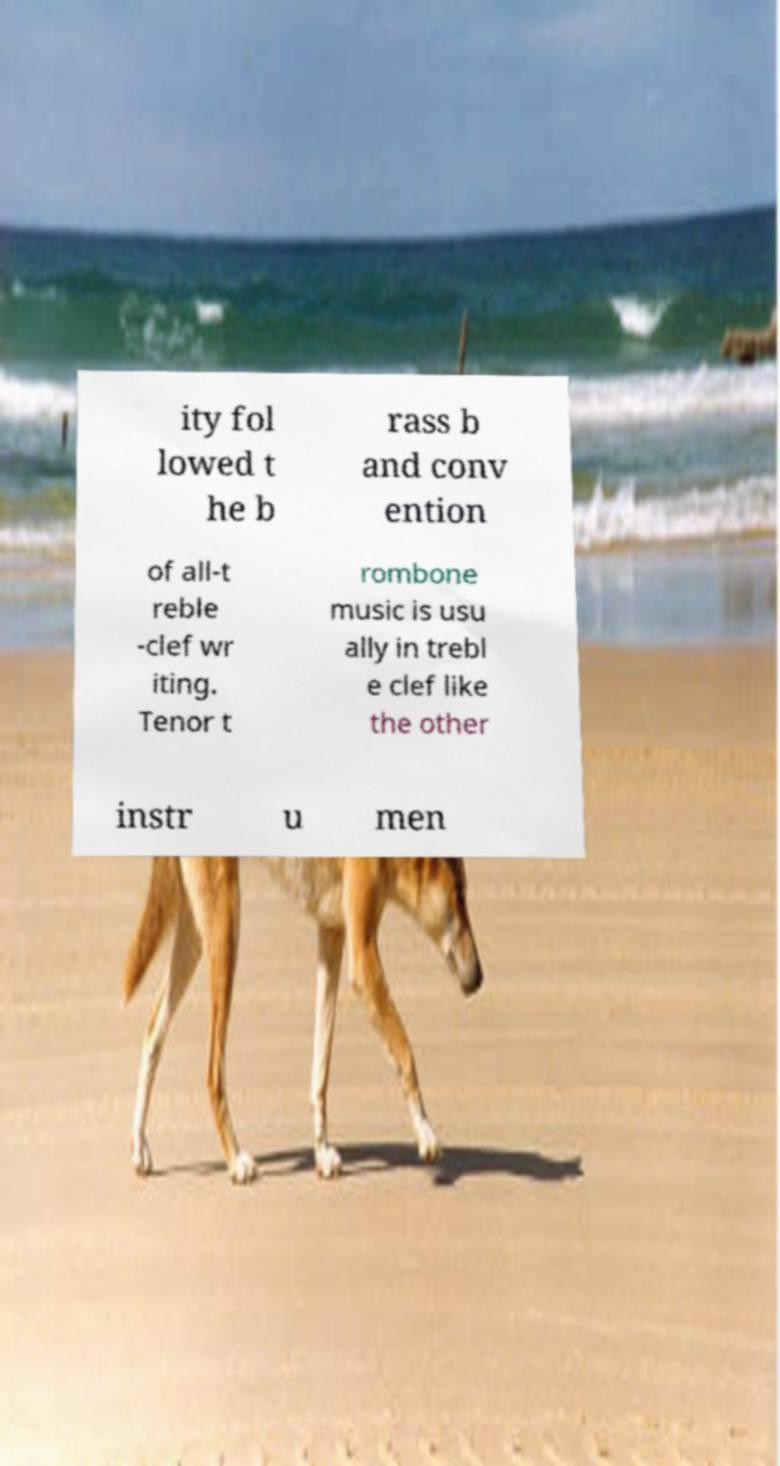Please read and relay the text visible in this image. What does it say? ity fol lowed t he b rass b and conv ention of all-t reble -clef wr iting. Tenor t rombone music is usu ally in trebl e clef like the other instr u men 